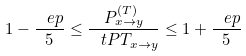<formula> <loc_0><loc_0><loc_500><loc_500>1 - \frac { \ e p } { 5 } \leq \frac { P ^ { ( T ) } _ { x \to y } } { \ t P T _ { x \to y } } \leq 1 + \frac { \ e p } { 5 }</formula> 